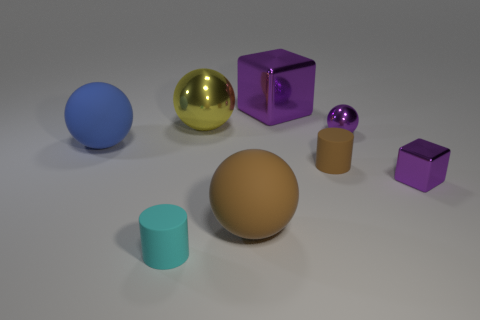What is the color of the big thing that is to the left of the large block and behind the blue thing?
Give a very brief answer. Yellow. There is a purple metal ball; is its size the same as the cube that is on the left side of the small brown rubber cylinder?
Keep it short and to the point. No. Is there anything else that has the same shape as the small brown rubber thing?
Your answer should be compact. Yes. What color is the other tiny thing that is the same shape as the cyan rubber thing?
Ensure brevity in your answer.  Brown. Do the blue matte thing and the yellow sphere have the same size?
Offer a terse response. Yes. How many other objects are there of the same size as the yellow metallic thing?
Your answer should be compact. 3. How many things are either objects that are behind the tiny metallic sphere or things that are in front of the big blue matte thing?
Your answer should be compact. 6. There is a shiny thing that is the same size as the purple ball; what is its shape?
Your answer should be very brief. Cube. What is the size of the cylinder that is the same material as the cyan object?
Offer a very short reply. Small. Is the shape of the yellow metal thing the same as the tiny cyan thing?
Offer a terse response. No. 